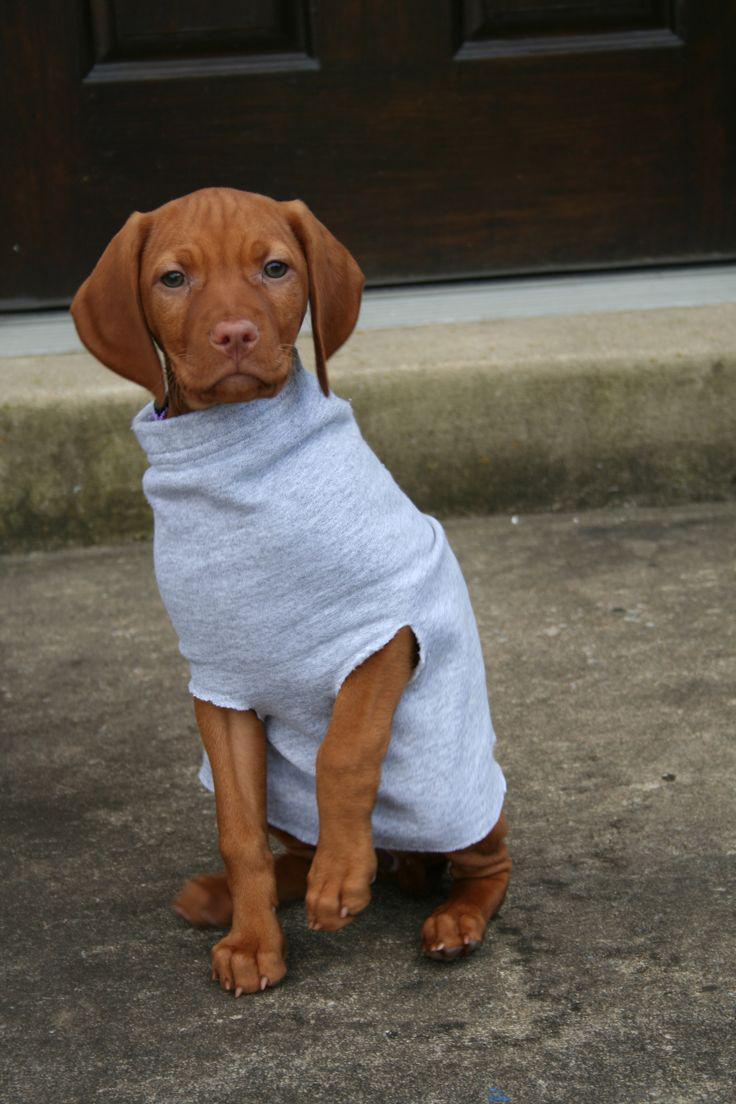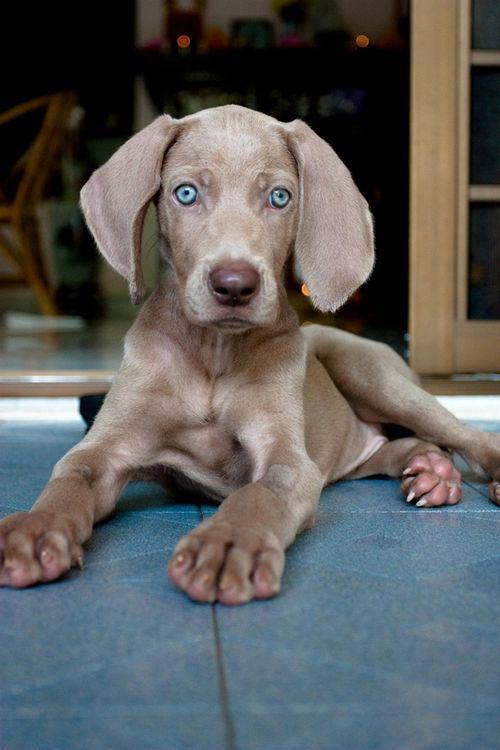The first image is the image on the left, the second image is the image on the right. Evaluate the accuracy of this statement regarding the images: "The dog on the right is reclining with front paws stretched in front of him and head raised, and the dog on the left is sitting uprgiht and wearing a pullover top.". Is it true? Answer yes or no. Yes. The first image is the image on the left, the second image is the image on the right. For the images displayed, is the sentence "One dog is wearing a turtleneck shirt." factually correct? Answer yes or no. Yes. 